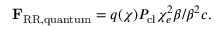<formula> <loc_0><loc_0><loc_500><loc_500>F _ { R R , q u a n t u m } = q ( \chi ) P _ { c l } \chi _ { e } ^ { 2 } \beta / \beta ^ { 2 } c .</formula> 